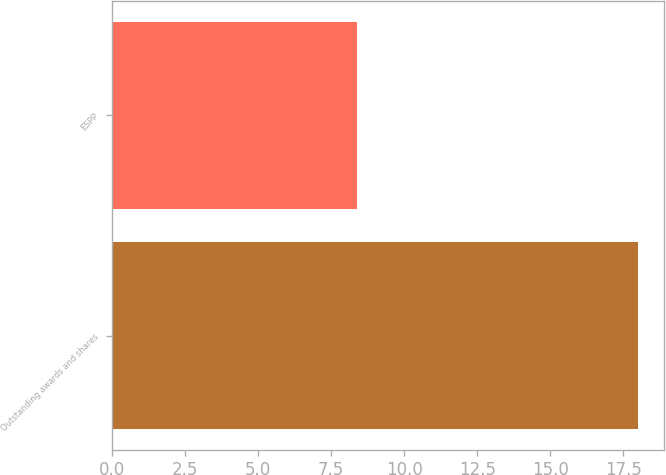Convert chart to OTSL. <chart><loc_0><loc_0><loc_500><loc_500><bar_chart><fcel>Outstanding awards and shares<fcel>ESPP<nl><fcel>18<fcel>8.4<nl></chart> 